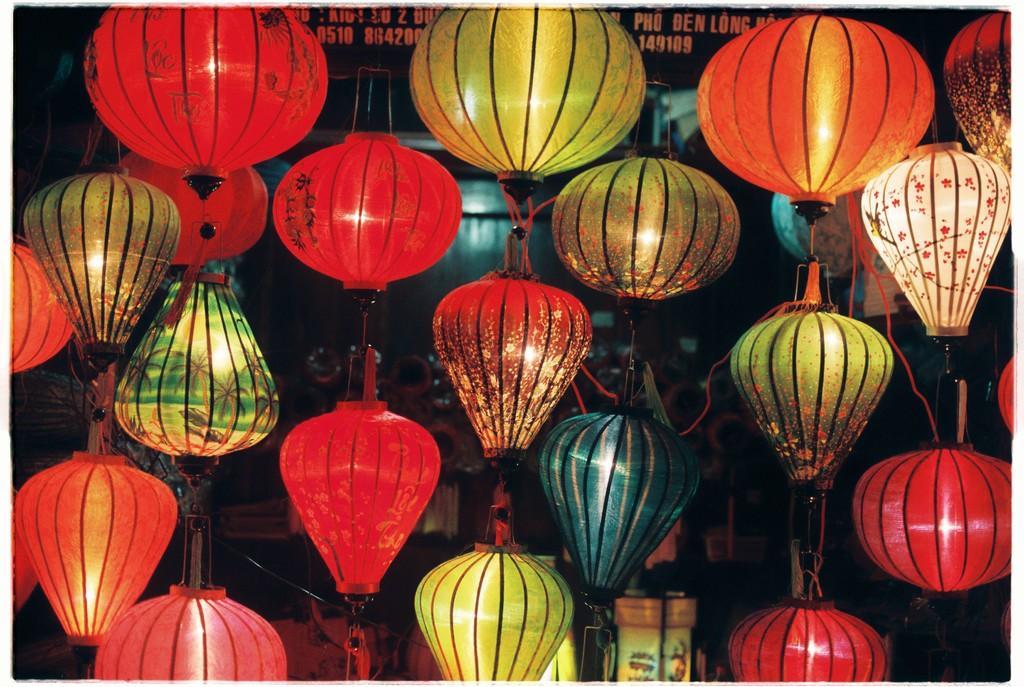Could you give a brief overview of what you see in this image? In this image I can see few light balls, they are in red, green, and orange color. Background I can see few objects. 